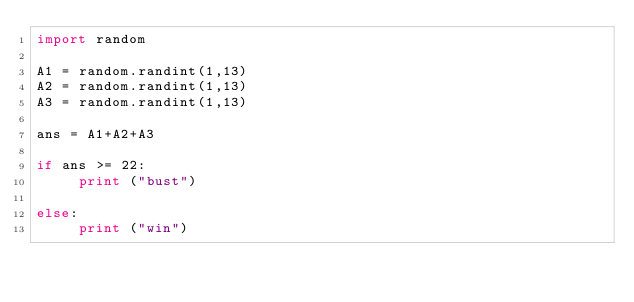Convert code to text. <code><loc_0><loc_0><loc_500><loc_500><_Python_>import random

A1 = random.randint(1,13)
A2 = random.randint(1,13)
A3 = random.randint(1,13)

ans = A1+A2+A3

if ans >= 22:
     print ("bust")

else:
     print ("win")</code> 